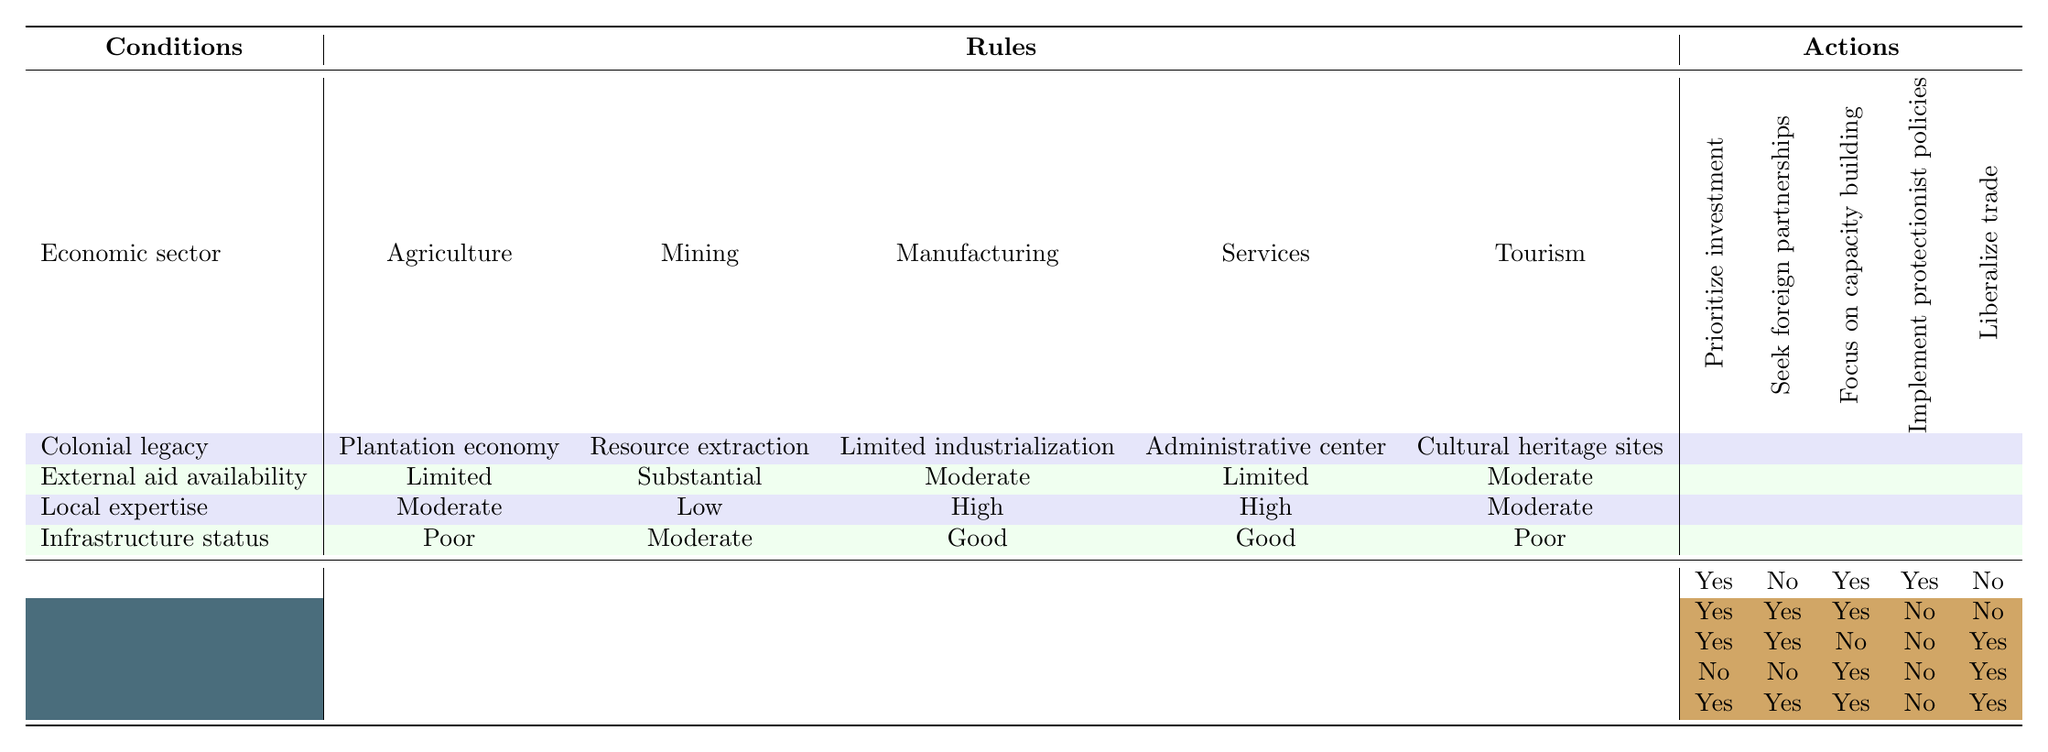What economic sector is prioritized for investment under a plantation economy legacy with limited external aid? Looking at the row for Agriculture under the column headings, prioritizing investment is marked as "Yes" where the colonial legacy is plantation economy and external aid availability is limited.
Answer: Agriculture How many sectors are encouraged to seek foreign partnerships? By examining the "Seek foreign partnerships" column, the sectors that have "Yes" are Mining, Manufacturing, and Tourism. There are three sectors in total that encourage seeking foreign partnerships.
Answer: 3 Is capacity building emphasized in the tourism sector? Referring to the row for Tourism and the "Focus on capacity building" column, it shows "Yes," indicating that capacity building is encouraged in that sector.
Answer: Yes In which economic sector is there a focus on capacity building despite having low local expertise? Looking at the table, the Services sector is the only sector (with high local expertise) that focuses on capacity building while having low external aid availability and is not directly concerned with its local expertise.
Answer: Services What is the relationship between local expertise and the decision to liberalize trade in the mining sector? In the Mining sector, the local expertise is low, and the decision to liberalize trade is marked as "No." This indicates that despite investment and partnerships being sought, the liberalization of trade is not favored due to its lack of local expertise.
Answer: No Which economic sector shows the most investment actions regardless of low local expertise and limited aid? When looking at the Mining sector, it shows "Yes" for prioritizing investment and capacity building and "Yes" for seeking foreign partnerships, despite having low local expertise and receiving substantial external aid. This indicates a strategic focus on investment in the sector.
Answer: Mining Are there any sectors that implement protectionist policies while also focusing on capacity building? Referring to the table, the Agriculture sector implements protectionist policies and focuses on capacity building. No other sectors have "Yes" for both conditions at the same time.
Answer: Yes What broader trends can be identified in the investment strategies across different sectors regarding colonial legacies? Analyzing the sectors, those with a plantation economy or resource extraction focus tend to prioritize investment and capacity building, while those with an administrative center or limited industrialization legacy emphasize capacity building and liberalized trade more. This suggests a strategic variation in investment approaches based on historical context.
Answer: Varies by sector 